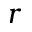<formula> <loc_0><loc_0><loc_500><loc_500>r</formula> 